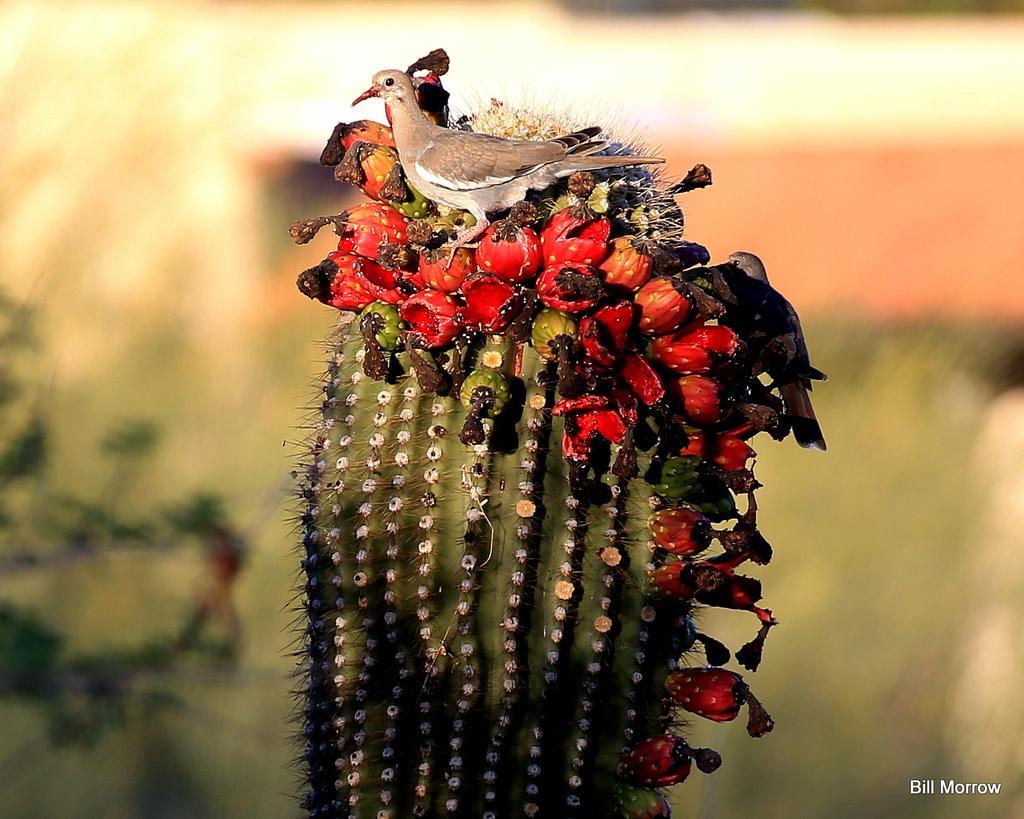Please provide a concise description of this image. In the center of the image, we can see a bird on the cactus plant and the background is blurry and we can see some plants. At the bottom, there is some text. 